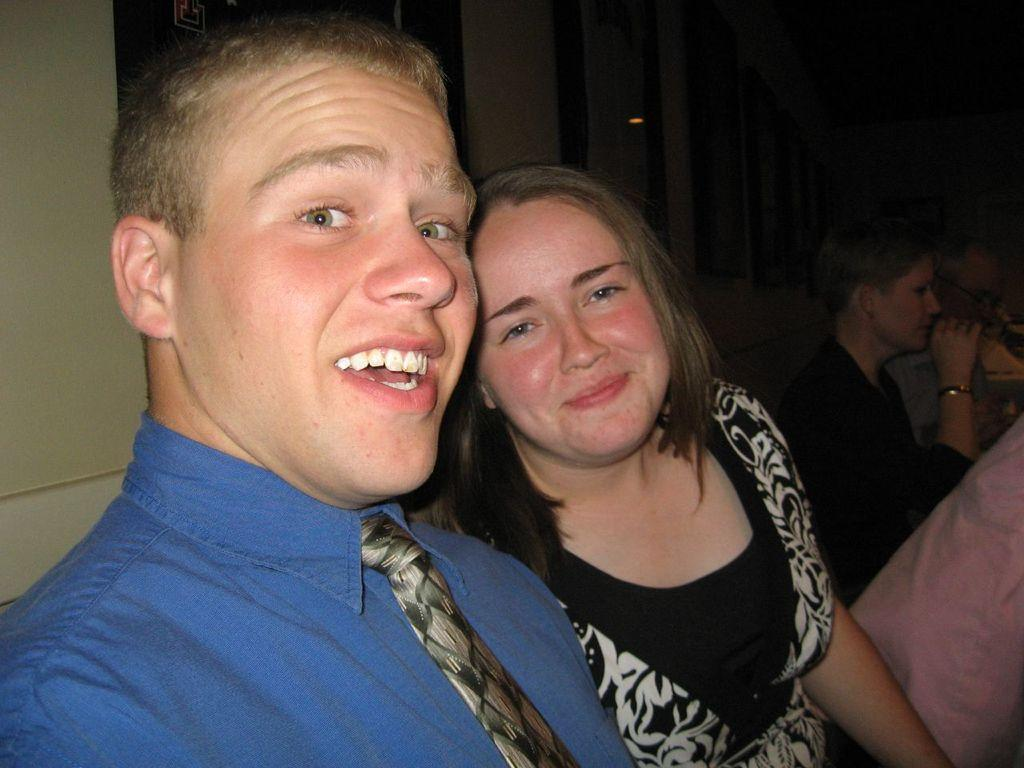What is the gender of the person in the image who is speaking? The person speaking in the image is a man. What is the man wearing in the image? The man is wearing a blue color shirt and a tie. What is the woman in the image doing? The woman is smiling. What is the woman wearing in the image? The woman is wearing a black color dress. What type of meat can be seen hanging from the man's tie in the image? There is no meat present in the image, nor is there any meat hanging from the man's tie. 